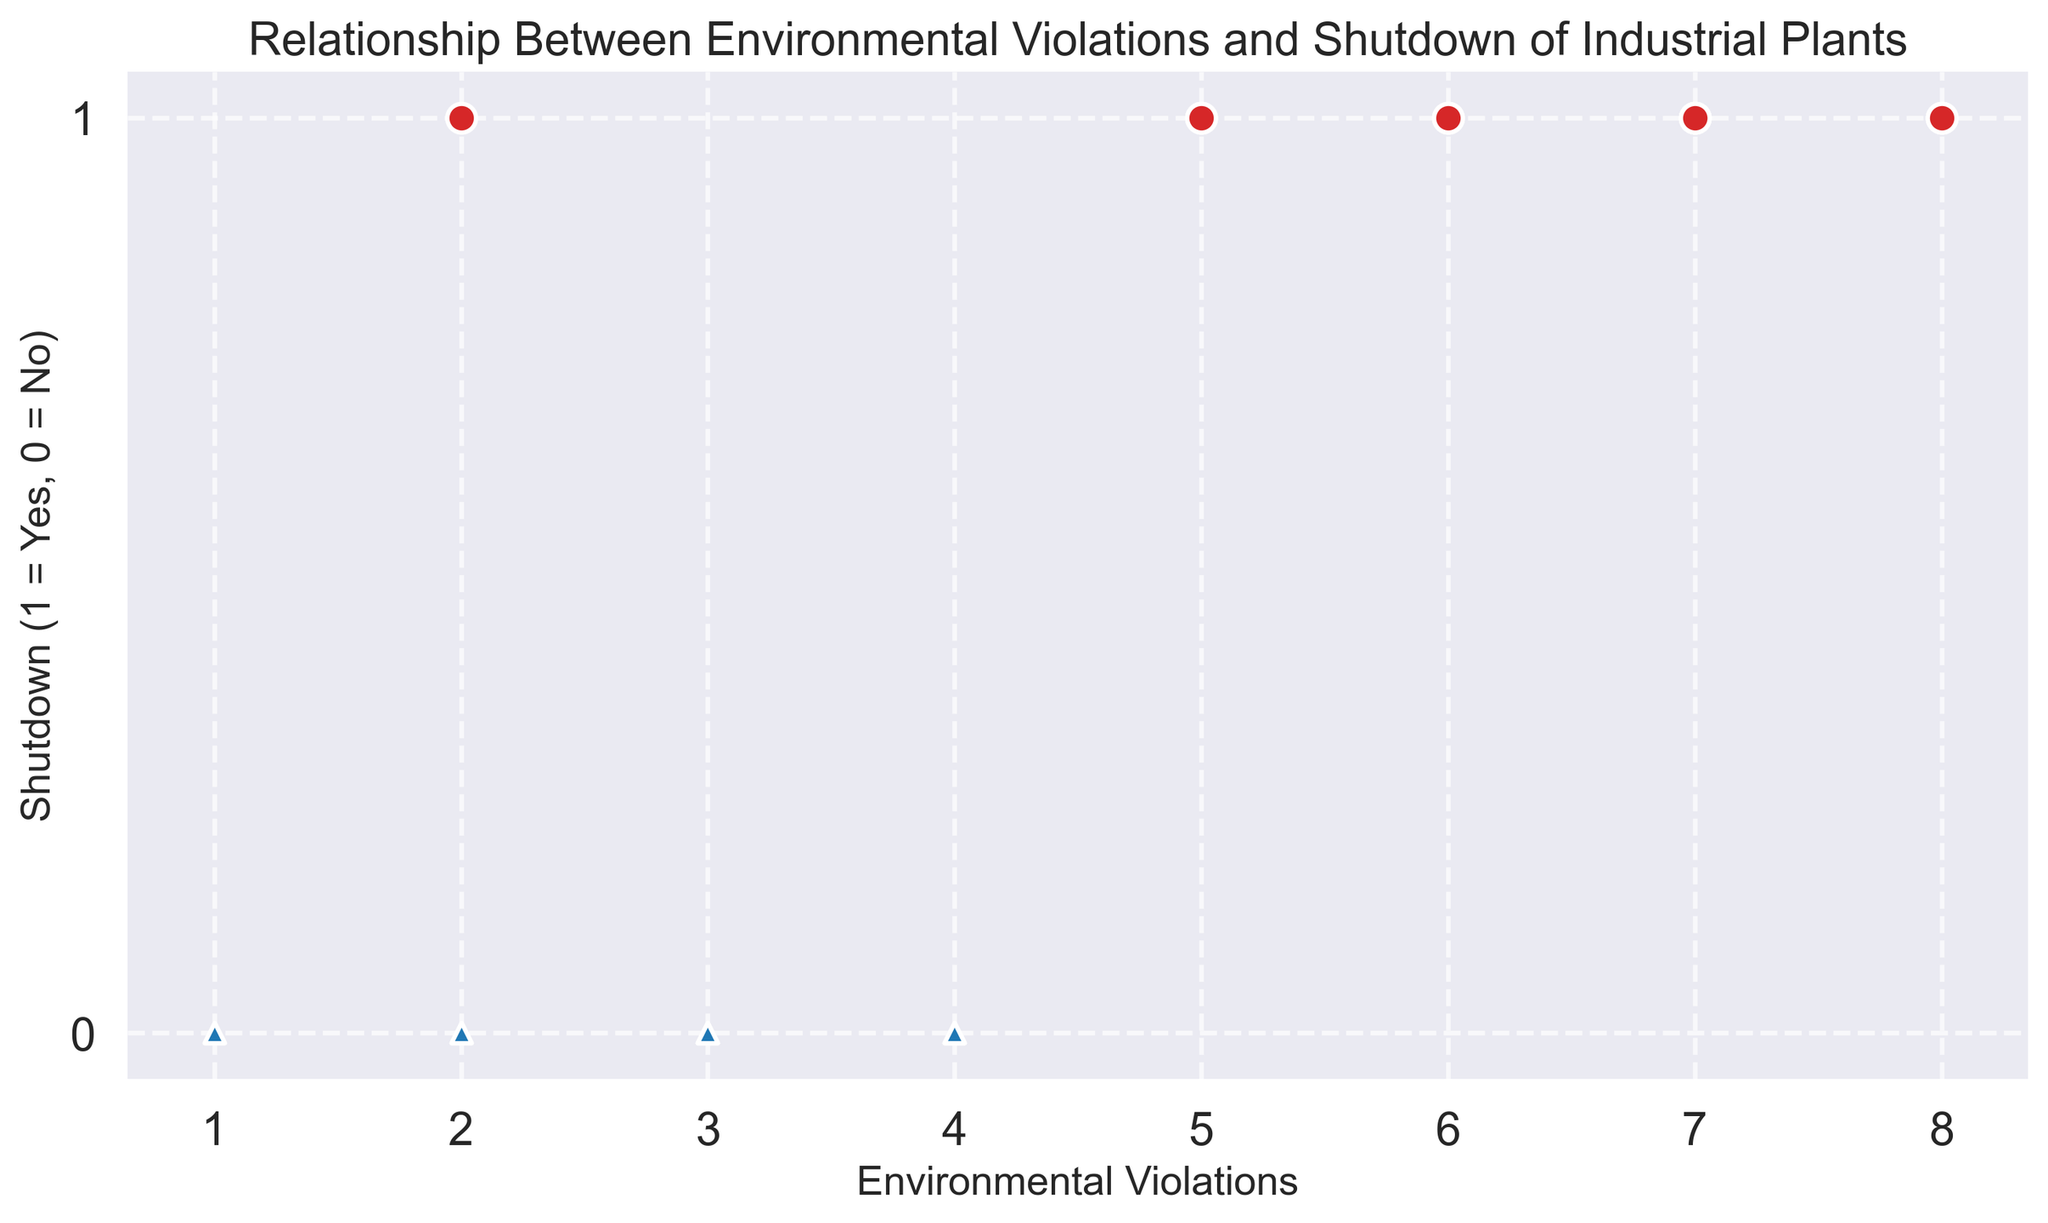How many more data points are there where shutdowns are represented as red circles compared to blue triangles? First, count the number of red circles (shutdowns = 1) by checking the points with `Shutdown` value of 1 which are depicted as red circles. Similarly, count the number of blue triangles (shutdowns = 0). Red circles: 10, Blue triangles: 10. Subtracting these gives 10 - 10 = 0.
Answer: 0 Which color corresponds to plants that have not been shut down? From the description, plants that have not been shut down (`Shutdown` = 0) are represented using blue triangles. Thus, blue corresponds to the plants that have not been shut down.
Answer: Blue What is the average number of environmental violations for plants that were shut down? Determine the points where `Shutdown` = 1, then sum the respective `Environmental_Violations` values and divide by the count of such points. The sum of violations for shut down plants is 2 + 5 + 7 + 6 + 8 + 7 + 5 + 6 + 7 + 8 = 61. Number of such points is 10. Therefore, 61 / 10 = 6.1.
Answer: 6.1 Is there any overlap in the range of environmental violations between plants that shut down and those that did not? Observe the range of `Environmental_Violations` for both categories. `Shutdown` = 1 has violations ranging from (2 to 8), while `Shutdown` = 0 ranges from (1 to 4). Both ranges overlap from 2 to 4.
Answer: Yes If a plant had 3 environmental violations, what is the likelihood it was shut down, based on the scatter plot? Look at the data points where `Environmental_Violations` = 3. You find 3 instances and identify the corresponding `Shutdown` values. 3 data points at violation=3 all have `Shutdown` = 0 (blue triangles). Therefore, based on the scatter plot, it's unlikely (0%) those plants shut down at 3 violations.
Answer: 0% What is the highest number of environmental violations observed for plants that did not shut down? Review the scatter plot to identify the highest `Environmental_Violations` value among blue triangles which represent not shut down plants. This maximum value is 4.
Answer: 4 How does the size of the markers relate to the shutdown status? By observing the scatter plot, larger markers (size 100) are used for shut down plants (red circles), whereas smaller markers (size 50) are for not shut down plants (blue triangles).
Answer: Larger markers are for shut down plants What is the common marker for plants that had 7 environmental violations? Identify the data points with `Environmental_Violations` of 7. Markers for these are all red circles. This indicates that all plants with 7 violations were shut down.
Answer: Red circles Is there a visible trend in the relationship between the number of environmental violations and the shutdown status? From the scatter plot, an observable trend is that plants with a higher number of environmental violations (typically above 4) are more likely to have been shut down (red circles dominate higher values).
Answer: Yes, more violations often lead to shutdown 